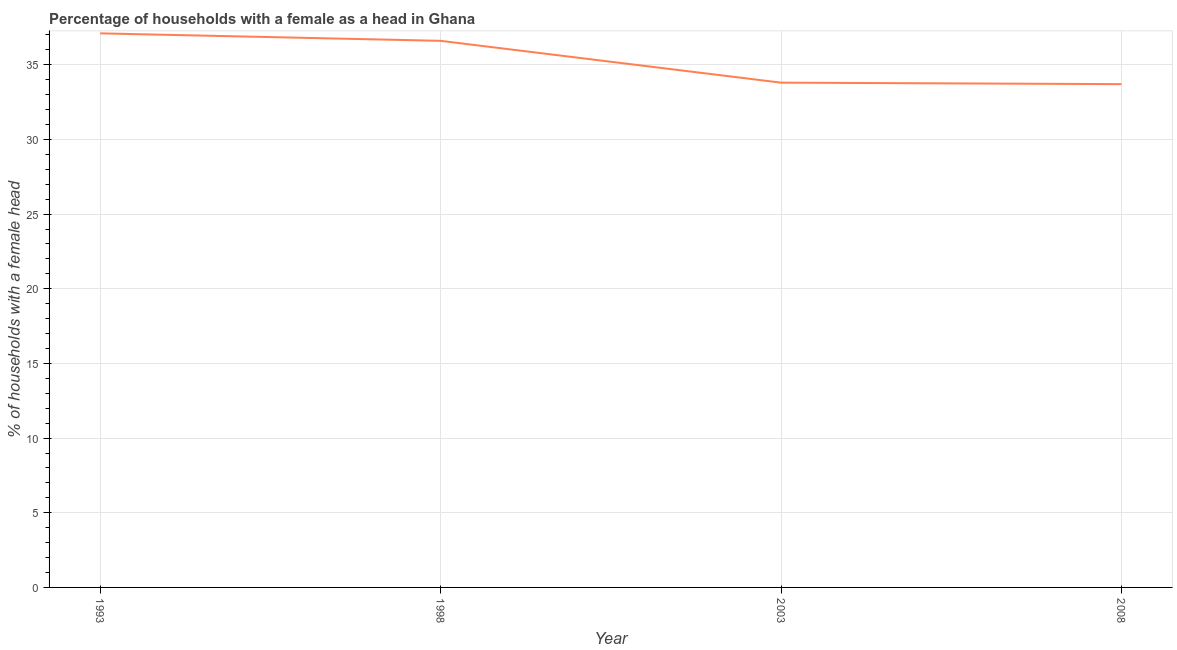What is the number of female supervised households in 1998?
Your answer should be very brief. 36.6. Across all years, what is the maximum number of female supervised households?
Your response must be concise. 37.1. Across all years, what is the minimum number of female supervised households?
Provide a short and direct response. 33.7. What is the sum of the number of female supervised households?
Make the answer very short. 141.2. What is the difference between the number of female supervised households in 1998 and 2003?
Keep it short and to the point. 2.8. What is the average number of female supervised households per year?
Your answer should be compact. 35.3. What is the median number of female supervised households?
Your answer should be compact. 35.2. In how many years, is the number of female supervised households greater than 34 %?
Provide a succinct answer. 2. Do a majority of the years between 1998 and 2008 (inclusive) have number of female supervised households greater than 4 %?
Offer a terse response. Yes. What is the ratio of the number of female supervised households in 2003 to that in 2008?
Offer a very short reply. 1. Is the number of female supervised households in 2003 less than that in 2008?
Ensure brevity in your answer.  No. Is the difference between the number of female supervised households in 1993 and 2008 greater than the difference between any two years?
Your answer should be compact. Yes. Is the sum of the number of female supervised households in 1998 and 2008 greater than the maximum number of female supervised households across all years?
Ensure brevity in your answer.  Yes. What is the difference between the highest and the lowest number of female supervised households?
Provide a succinct answer. 3.4. In how many years, is the number of female supervised households greater than the average number of female supervised households taken over all years?
Ensure brevity in your answer.  2. Does the number of female supervised households monotonically increase over the years?
Give a very brief answer. No. How many lines are there?
Give a very brief answer. 1. Are the values on the major ticks of Y-axis written in scientific E-notation?
Ensure brevity in your answer.  No. Does the graph contain any zero values?
Provide a short and direct response. No. Does the graph contain grids?
Keep it short and to the point. Yes. What is the title of the graph?
Your answer should be compact. Percentage of households with a female as a head in Ghana. What is the label or title of the X-axis?
Provide a succinct answer. Year. What is the label or title of the Y-axis?
Your answer should be very brief. % of households with a female head. What is the % of households with a female head in 1993?
Make the answer very short. 37.1. What is the % of households with a female head in 1998?
Keep it short and to the point. 36.6. What is the % of households with a female head in 2003?
Your response must be concise. 33.8. What is the % of households with a female head in 2008?
Keep it short and to the point. 33.7. What is the difference between the % of households with a female head in 1993 and 1998?
Provide a succinct answer. 0.5. What is the difference between the % of households with a female head in 1993 and 2003?
Your response must be concise. 3.3. What is the difference between the % of households with a female head in 1998 and 2003?
Your answer should be compact. 2.8. What is the difference between the % of households with a female head in 1998 and 2008?
Offer a terse response. 2.9. What is the ratio of the % of households with a female head in 1993 to that in 2003?
Your response must be concise. 1.1. What is the ratio of the % of households with a female head in 1993 to that in 2008?
Keep it short and to the point. 1.1. What is the ratio of the % of households with a female head in 1998 to that in 2003?
Ensure brevity in your answer.  1.08. What is the ratio of the % of households with a female head in 1998 to that in 2008?
Make the answer very short. 1.09. What is the ratio of the % of households with a female head in 2003 to that in 2008?
Give a very brief answer. 1. 